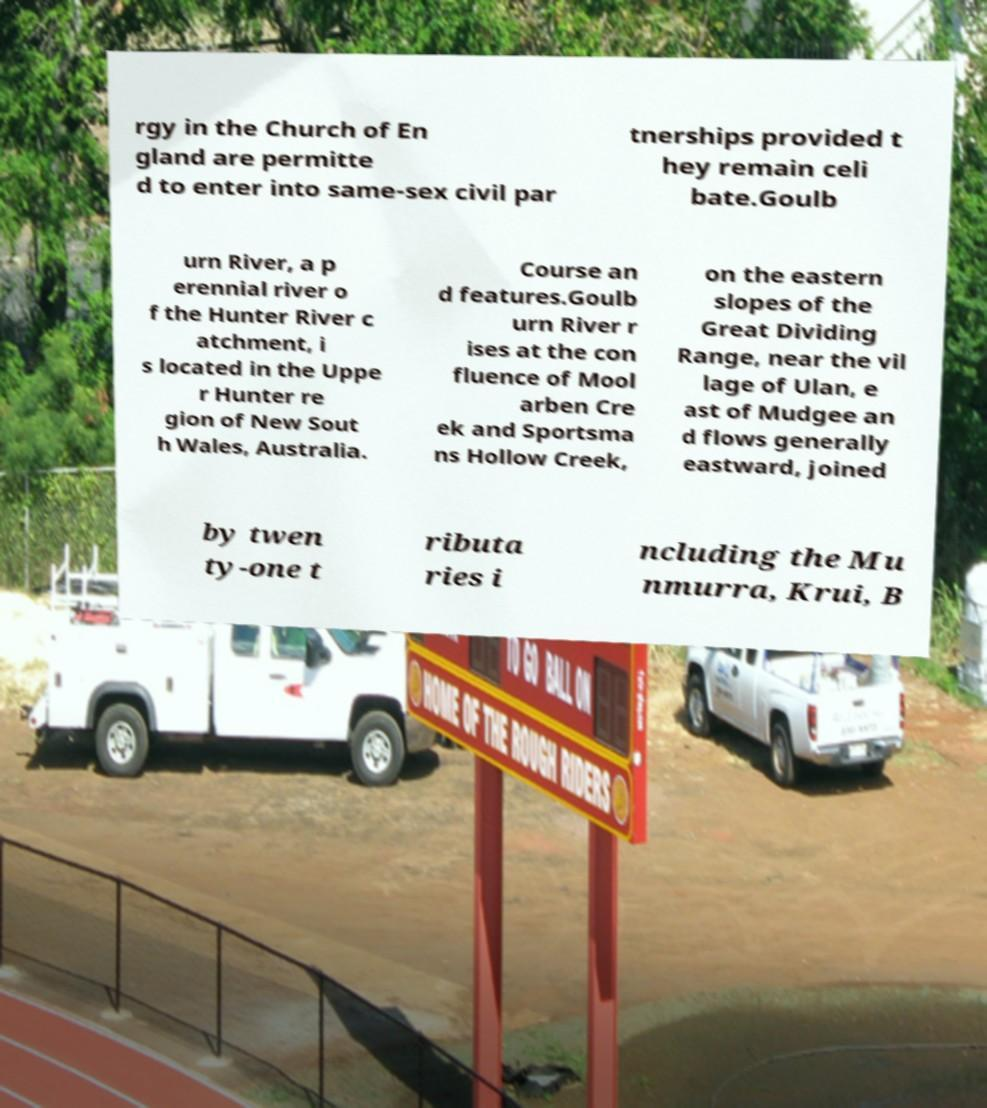I need the written content from this picture converted into text. Can you do that? rgy in the Church of En gland are permitte d to enter into same-sex civil par tnerships provided t hey remain celi bate.Goulb urn River, a p erennial river o f the Hunter River c atchment, i s located in the Uppe r Hunter re gion of New Sout h Wales, Australia. Course an d features.Goulb urn River r ises at the con fluence of Mool arben Cre ek and Sportsma ns Hollow Creek, on the eastern slopes of the Great Dividing Range, near the vil lage of Ulan, e ast of Mudgee an d flows generally eastward, joined by twen ty-one t ributa ries i ncluding the Mu nmurra, Krui, B 